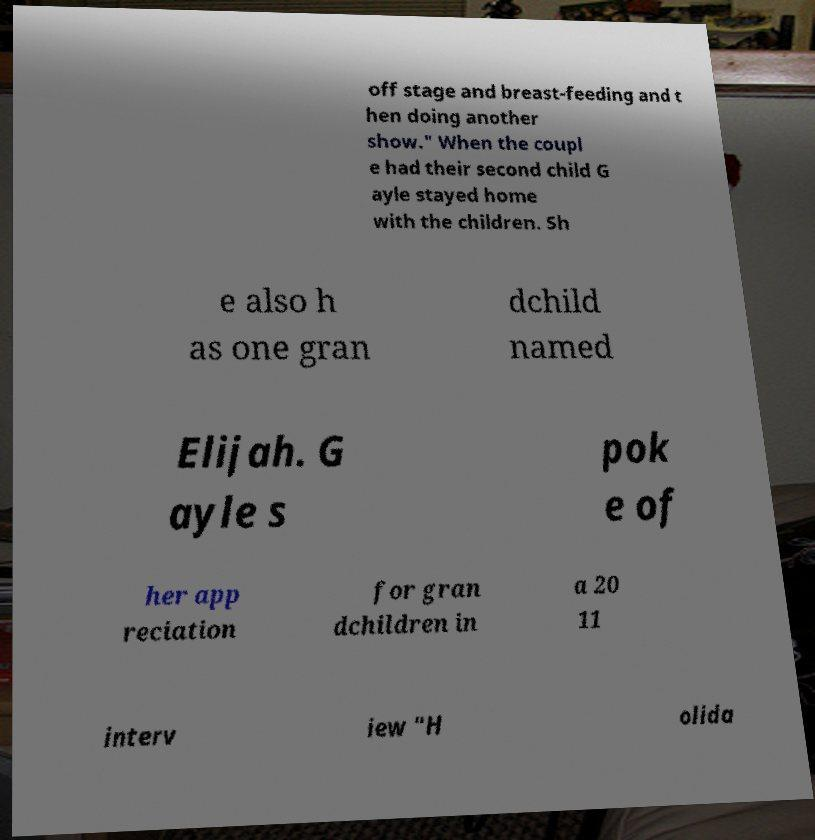Please read and relay the text visible in this image. What does it say? off stage and breast-feeding and t hen doing another show." When the coupl e had their second child G ayle stayed home with the children. Sh e also h as one gran dchild named Elijah. G ayle s pok e of her app reciation for gran dchildren in a 20 11 interv iew "H olida 